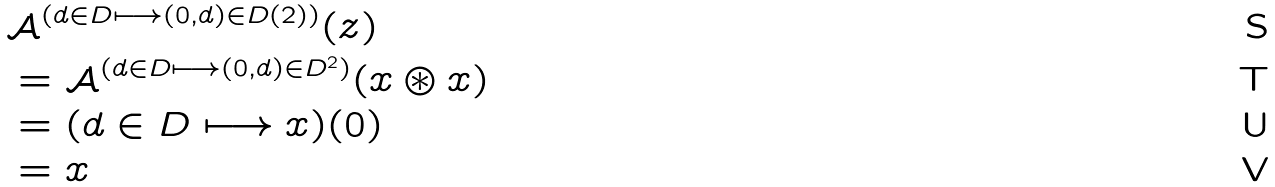<formula> <loc_0><loc_0><loc_500><loc_500>& \mathcal { A } ^ { ( d \in D \longmapsto ( 0 , d ) \in D ( 2 ) ) } ( z ) \\ & = \mathcal { A } ^ { ( d \in D \longmapsto ( 0 , d ) \in D ^ { 2 } ) } ( x \circledast x ) \\ & = ( d \in D \longmapsto x ) ( 0 ) \\ & = x</formula> 